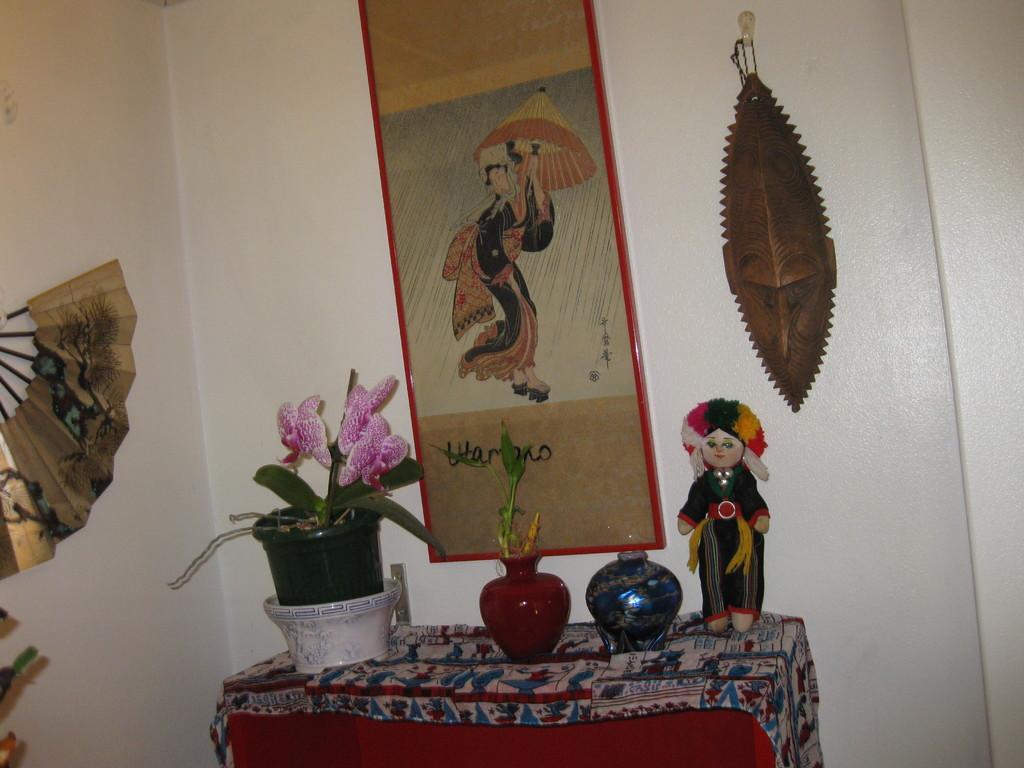How would you summarize this image in a sentence or two? In this image, we can see a table covered with cloth and some objects like a flower pot and a doll are placed on it. We can see the wall with an object and a photo frame. We can also see an object on the left. 